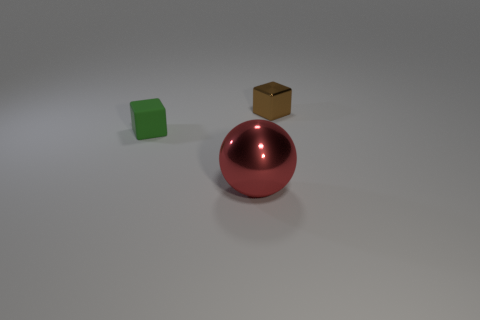Can you tell me the material of the objects in the image? The objects appear to be computer-generated and they simulate a green cylinder that could be made of plastic, a brown cube that resembles cardboard or wood, and a red sphere with a reflective surface that might represent a metal or glass material. 